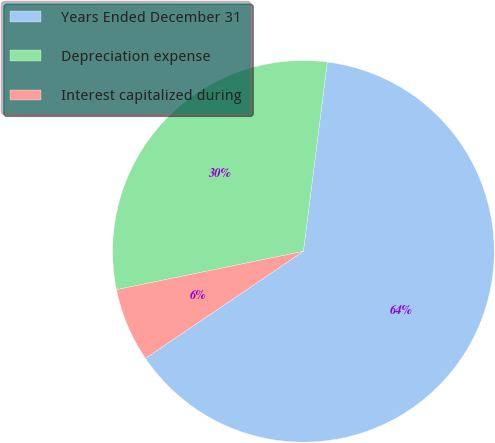<chart> <loc_0><loc_0><loc_500><loc_500><pie_chart><fcel>Years Ended December 31<fcel>Depreciation expense<fcel>Interest capitalized during<nl><fcel>63.52%<fcel>30.22%<fcel>6.26%<nl></chart> 